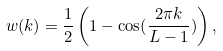Convert formula to latex. <formula><loc_0><loc_0><loc_500><loc_500>w ( k ) = \frac { 1 } { 2 } \left ( 1 - \cos ( \frac { 2 \pi k } { L - 1 } ) \right ) ,</formula> 